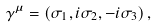<formula> <loc_0><loc_0><loc_500><loc_500>\gamma ^ { \mu } = \left ( \sigma _ { 1 } , i \sigma _ { 2 } , - i \sigma _ { 3 } \right ) ,</formula> 